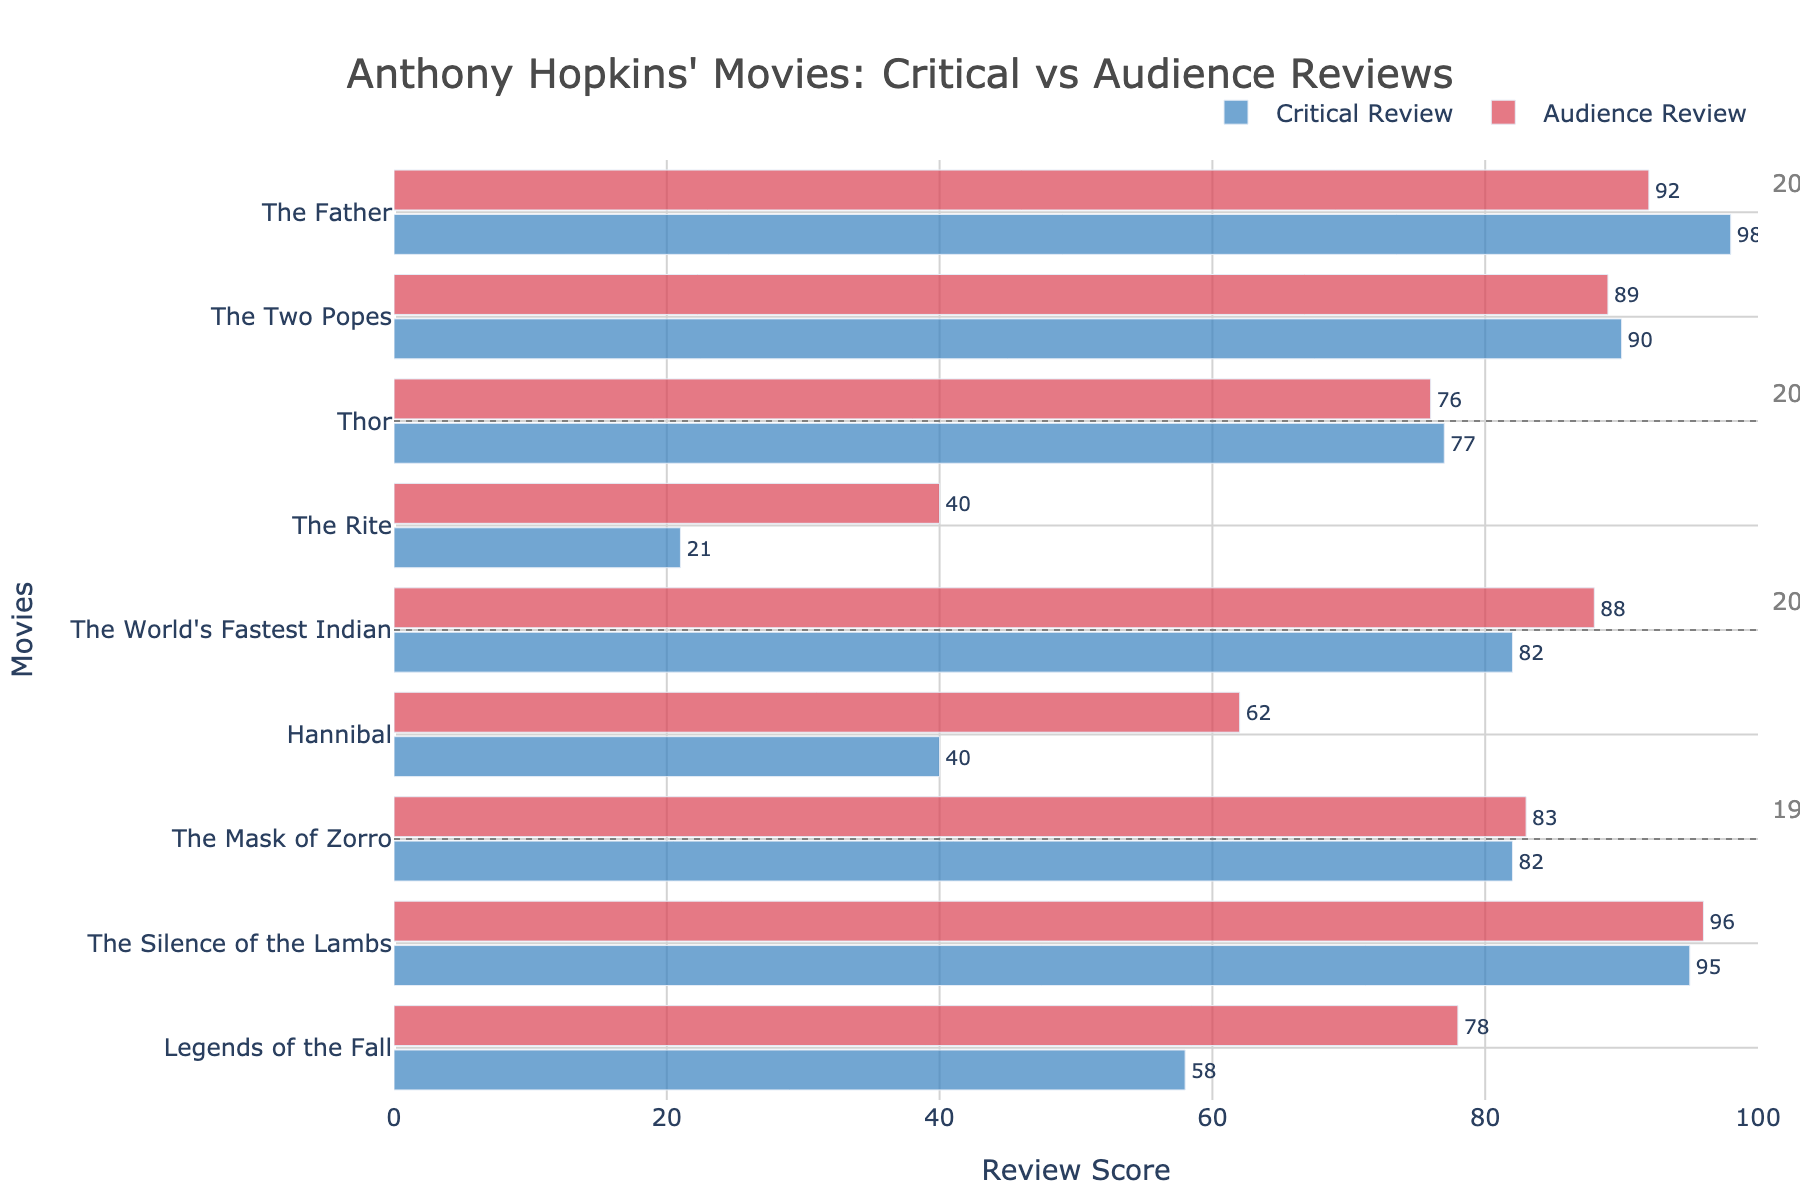What is the overall difference between the highest and lowest Critical Review Scores in the figure? To find the overall difference, identify the highest Critical Review Score (98 for "The Father") and the lowest (21 for "The Rite"). The difference is calculated as 98 - 21.
Answer: 77 Which movie in the 1990s has the smallest difference between critical and audience reviews? For the 1990s movies, compare the differences in review scores for each movie: "The Silence of the Lambs" has a 1-point difference (96 - 95), "Legends of the Fall" has a 20-point difference (78 - 58), and "The Mask of Zorro" has a 1-point difference (83 - 82). Both "The Silence of the Lambs" and "The Mask of Zorro" have the smallest difference.
Answer: The Silence of the Lambs, The Mask of Zorro (tie) How many movies in the 2000s received a Critical Review Score above 70? In the 2000s, check the Critical Review Scores: "Hannibal" (40), "The World's Fastest Indian" (82). Only "The World's Fastest Indian" has a score above 70.
Answer: 1 What is the average Audience Review Score for movies in the 2010s? List the Audience Review Scores for 2010s movies: "Thor" (76) and "The Rite" (40). The average is calculated as (76 + 40) / 2 = 58.
Answer: 58 In which decade was there the largest gap between a critical and audience review for any movie? Evaluate the differences in review scores for each movie in each decade to find the maximum gap: 1990s ("Legends of the Fall" 20 points), 2000s ("Hannibal" 22 points), 2010s ("The Rite" 19 points), 2020s ("The Father" 6 points). The largest gap is found in the 2000s for "Hannibal" with 22 points.
Answer: 2000s Which movie has the highest Audience Review Score? Compare all Audience Review Scores in the figure: "The Silence of the Lambs" (96), "Legends of the Fall" (78), "The Mask of Zorro" (83), "Hannibal" (62), "The World's Fastest Indian" (88), "Thor" (76), "The Rite" (40), "The Father" (92), "The Two Popes" (89). The highest score is 96 for "The Silence of the Lambs."
Answer: The Silence of the Lambs What percentage of movies have a higher Critical Review Score than an Audience Review Score? Count the total number of movies (9) and the number of movies with higher Critical Review Scores: "The Silence of the Lambs," "The Mask of Zorro," "Hannibal," "Thor." There are 4 such movies. Calculate the percentage as (4 / 9) * 100.
Answer: 44.44% Which decade has the most consistently high review scores (both critical and audience above 75)? Check which movies in each decade have both scores above 75: 1990s ("The Silence of the Lambs," "The Mask of Zorro"), 2000s ("The World's Fastest Indian"), 2010s (none), 2020s ("The Father," "The Two Popes"). The 2020s have the most consistently high reviews with two movies meeting the criteria.
Answer: 2020s 